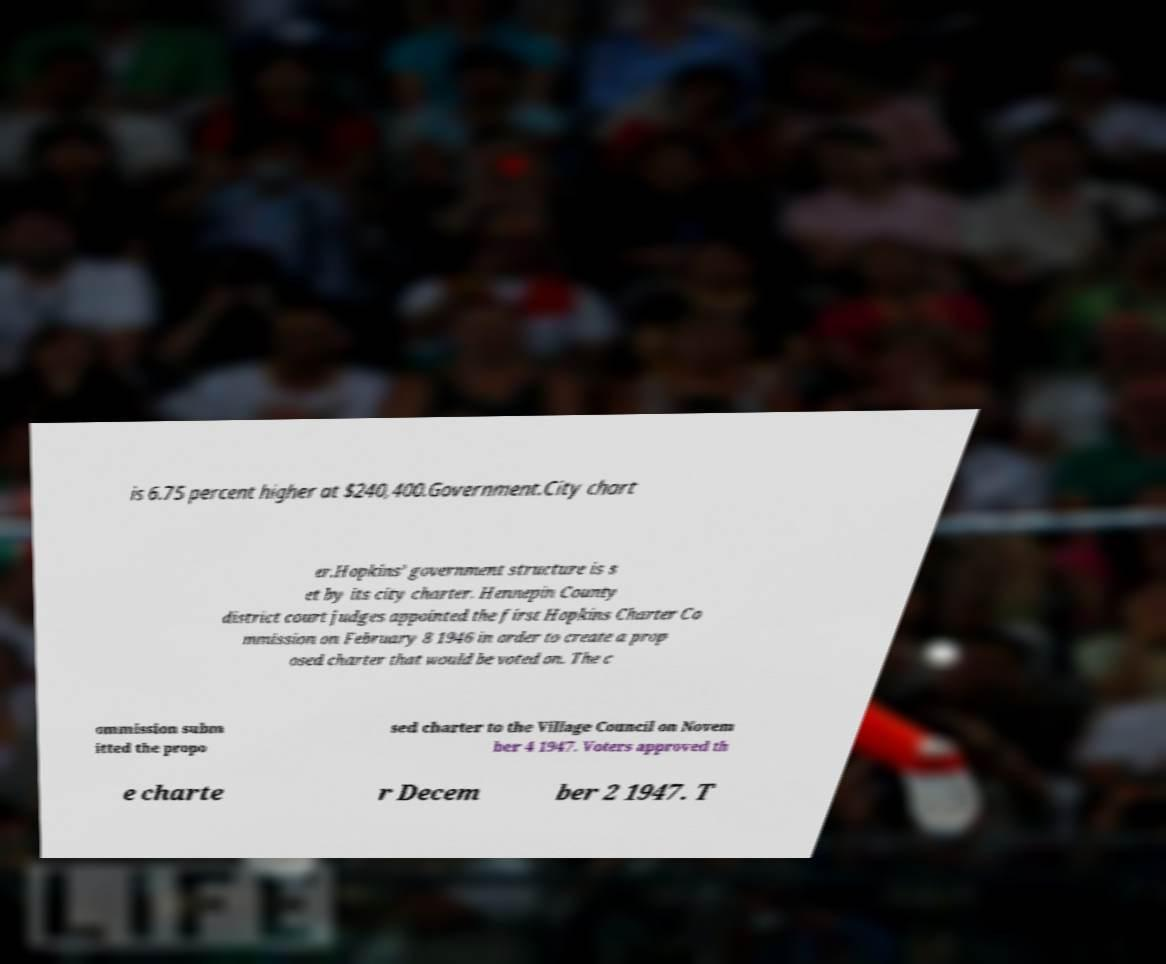For documentation purposes, I need the text within this image transcribed. Could you provide that? is 6.75 percent higher at $240,400.Government.City chart er.Hopkins’ government structure is s et by its city charter. Hennepin County district court judges appointed the first Hopkins Charter Co mmission on February 8 1946 in order to create a prop osed charter that would be voted on. The c ommission subm itted the propo sed charter to the Village Council on Novem ber 4 1947. Voters approved th e charte r Decem ber 2 1947. T 